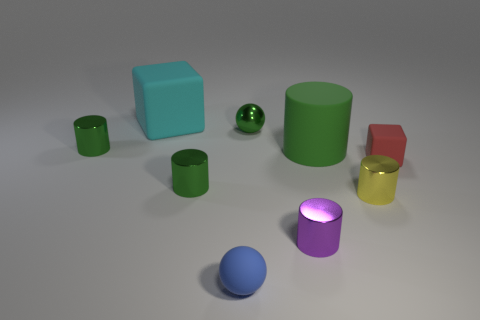Subtract all green cylinders. How many were subtracted if there are1green cylinders left? 2 Add 1 large matte cubes. How many objects exist? 10 Subtract all rubber cylinders. How many cylinders are left? 4 Subtract all cubes. How many objects are left? 7 Subtract all cyan cubes. How many cubes are left? 1 Subtract 3 cylinders. How many cylinders are left? 2 Add 1 small balls. How many small balls exist? 3 Subtract 1 cyan blocks. How many objects are left? 8 Subtract all brown cylinders. Subtract all purple blocks. How many cylinders are left? 5 Subtract all green cubes. How many green spheres are left? 1 